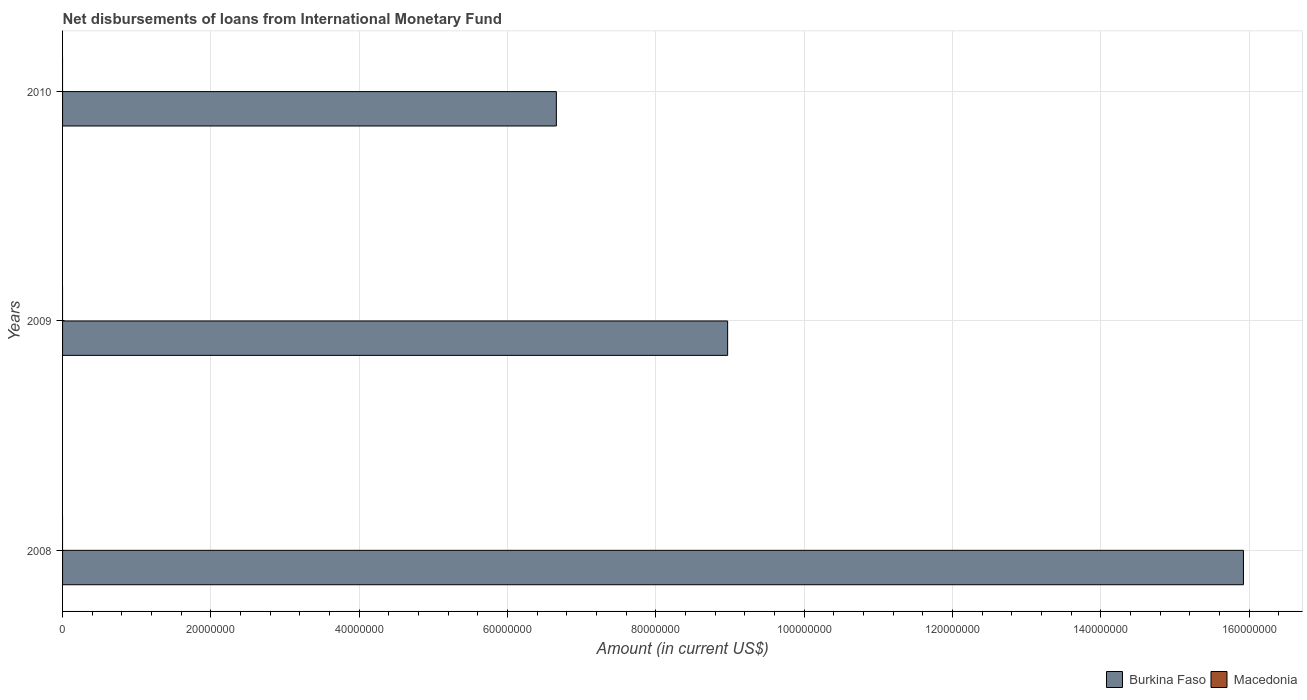Are the number of bars per tick equal to the number of legend labels?
Make the answer very short. No. How many bars are there on the 2nd tick from the top?
Give a very brief answer. 1. How many bars are there on the 2nd tick from the bottom?
Make the answer very short. 1. What is the amount of loans disbursed in Burkina Faso in 2008?
Your answer should be very brief. 1.59e+08. In which year was the amount of loans disbursed in Burkina Faso maximum?
Keep it short and to the point. 2008. What is the total amount of loans disbursed in Burkina Faso in the graph?
Provide a short and direct response. 3.15e+08. What is the difference between the amount of loans disbursed in Burkina Faso in 2009 and that in 2010?
Provide a succinct answer. 2.31e+07. What is the difference between the amount of loans disbursed in Burkina Faso in 2009 and the amount of loans disbursed in Macedonia in 2008?
Ensure brevity in your answer.  8.97e+07. What is the average amount of loans disbursed in Burkina Faso per year?
Offer a terse response. 1.05e+08. In how many years, is the amount of loans disbursed in Burkina Faso greater than 128000000 US$?
Your answer should be very brief. 1. What is the ratio of the amount of loans disbursed in Burkina Faso in 2008 to that in 2009?
Provide a succinct answer. 1.78. What is the difference between the highest and the second highest amount of loans disbursed in Burkina Faso?
Ensure brevity in your answer.  6.95e+07. What is the difference between the highest and the lowest amount of loans disbursed in Burkina Faso?
Provide a short and direct response. 9.26e+07. How many bars are there?
Your response must be concise. 3. Are all the bars in the graph horizontal?
Offer a very short reply. Yes. How many years are there in the graph?
Offer a very short reply. 3. Does the graph contain grids?
Give a very brief answer. Yes. How many legend labels are there?
Provide a short and direct response. 2. How are the legend labels stacked?
Keep it short and to the point. Horizontal. What is the title of the graph?
Your response must be concise. Net disbursements of loans from International Monetary Fund. Does "East Asia (all income levels)" appear as one of the legend labels in the graph?
Your answer should be very brief. No. What is the label or title of the X-axis?
Your response must be concise. Amount (in current US$). What is the Amount (in current US$) of Burkina Faso in 2008?
Offer a very short reply. 1.59e+08. What is the Amount (in current US$) in Macedonia in 2008?
Ensure brevity in your answer.  0. What is the Amount (in current US$) in Burkina Faso in 2009?
Your response must be concise. 8.97e+07. What is the Amount (in current US$) of Burkina Faso in 2010?
Keep it short and to the point. 6.66e+07. What is the Amount (in current US$) in Macedonia in 2010?
Your answer should be compact. 0. Across all years, what is the maximum Amount (in current US$) of Burkina Faso?
Ensure brevity in your answer.  1.59e+08. Across all years, what is the minimum Amount (in current US$) in Burkina Faso?
Keep it short and to the point. 6.66e+07. What is the total Amount (in current US$) of Burkina Faso in the graph?
Provide a short and direct response. 3.15e+08. What is the difference between the Amount (in current US$) in Burkina Faso in 2008 and that in 2009?
Make the answer very short. 6.95e+07. What is the difference between the Amount (in current US$) in Burkina Faso in 2008 and that in 2010?
Your answer should be compact. 9.26e+07. What is the difference between the Amount (in current US$) of Burkina Faso in 2009 and that in 2010?
Keep it short and to the point. 2.31e+07. What is the average Amount (in current US$) of Burkina Faso per year?
Your response must be concise. 1.05e+08. What is the ratio of the Amount (in current US$) in Burkina Faso in 2008 to that in 2009?
Make the answer very short. 1.78. What is the ratio of the Amount (in current US$) of Burkina Faso in 2008 to that in 2010?
Your answer should be compact. 2.39. What is the ratio of the Amount (in current US$) of Burkina Faso in 2009 to that in 2010?
Give a very brief answer. 1.35. What is the difference between the highest and the second highest Amount (in current US$) in Burkina Faso?
Keep it short and to the point. 6.95e+07. What is the difference between the highest and the lowest Amount (in current US$) of Burkina Faso?
Your response must be concise. 9.26e+07. 